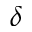Convert formula to latex. <formula><loc_0><loc_0><loc_500><loc_500>\delta</formula> 